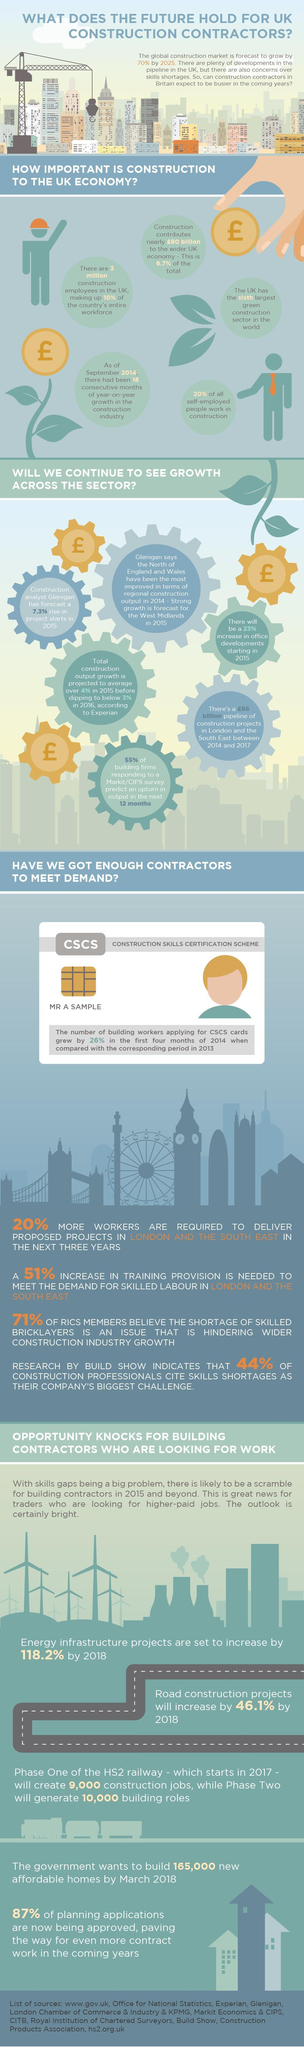What percentage of all self occupied people do not work in the construction sector?
Answer the question with a short phrase. 80 What position UK has achieved in the green construction sector? sixth What is the expected growth of offices in UK in 2015? 23% 